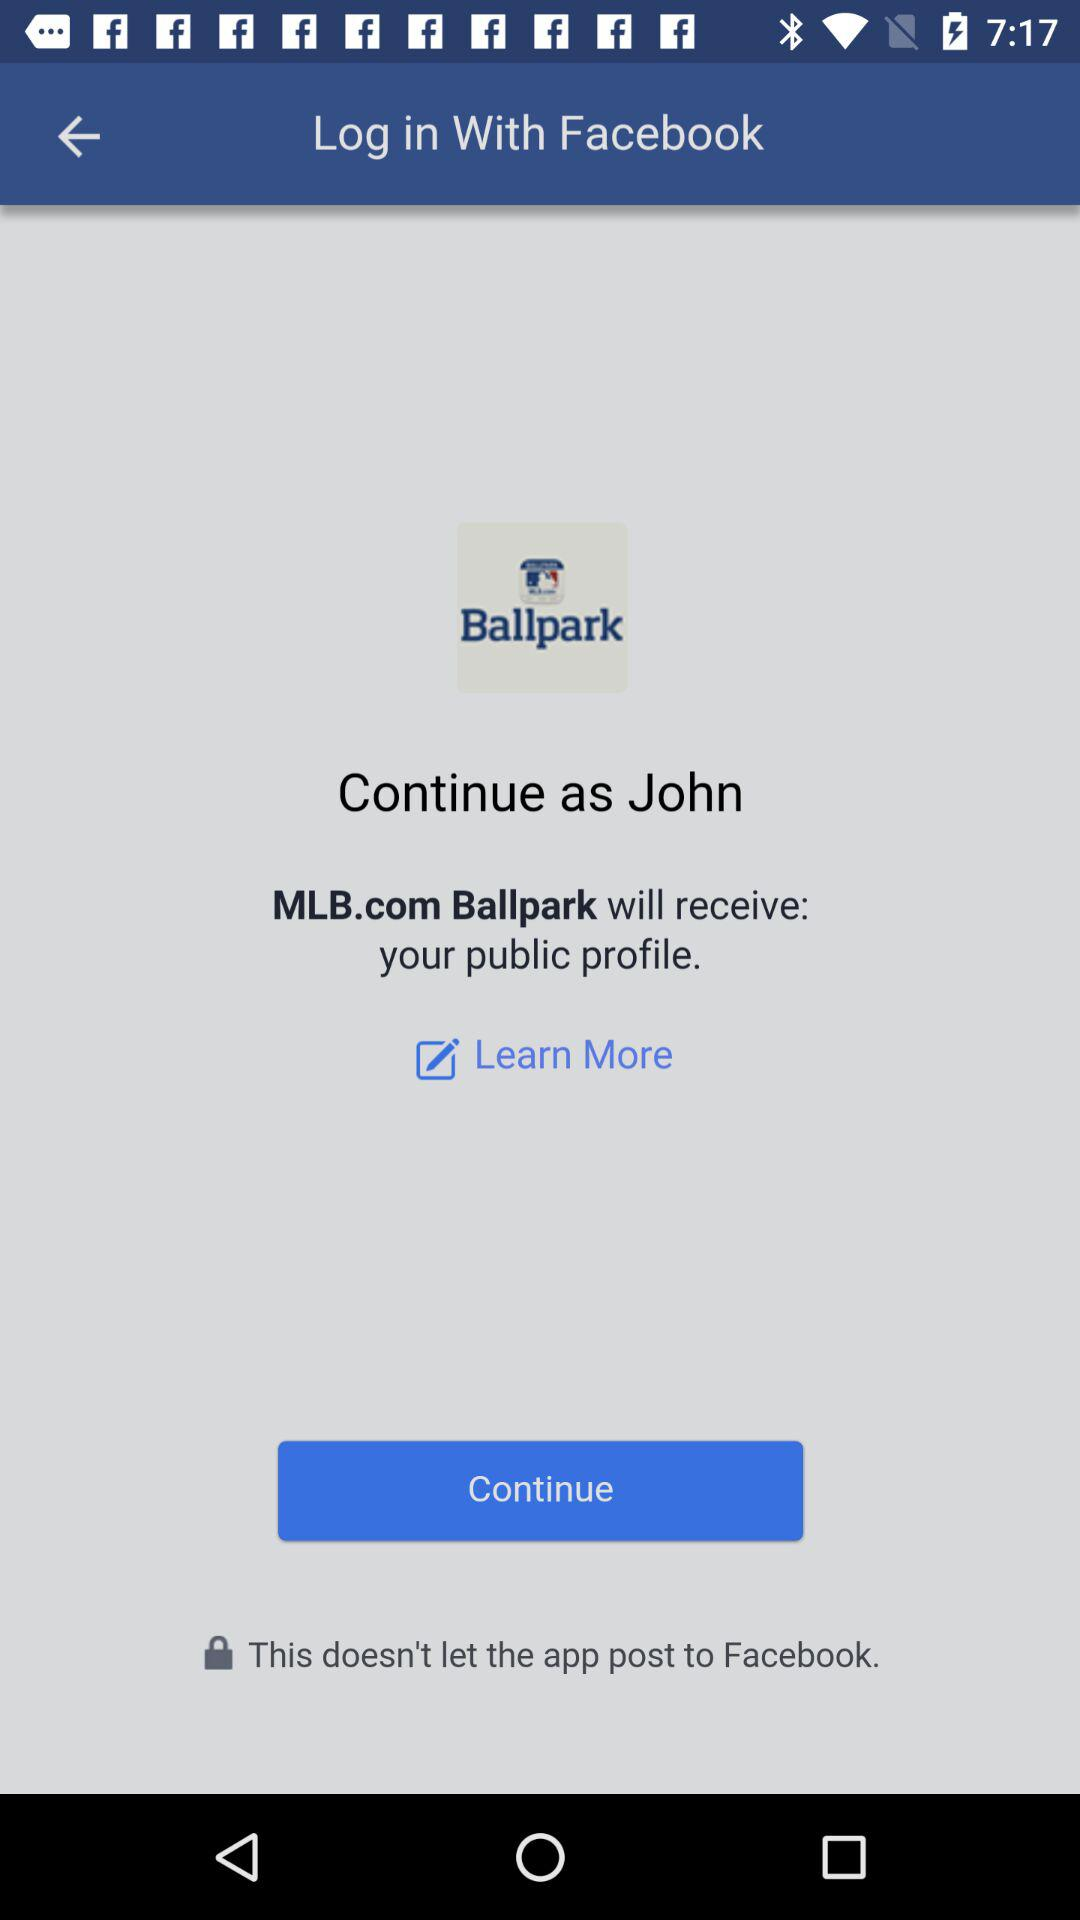What is John's last name?
When the provided information is insufficient, respond with <no answer>. <no answer> 